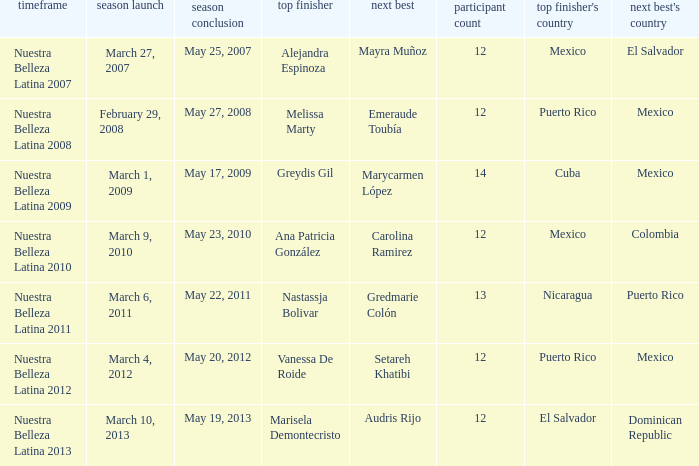How many contestants were there in a season where alejandra espinoza won? 1.0. 